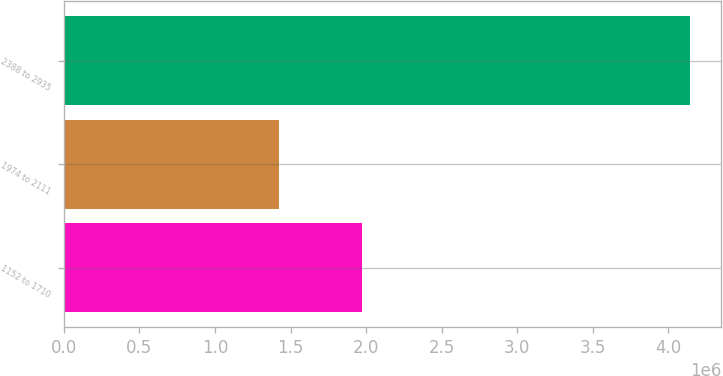<chart> <loc_0><loc_0><loc_500><loc_500><bar_chart><fcel>1152 to 1710<fcel>1974 to 2111<fcel>2388 to 2935<nl><fcel>1.97259e+06<fcel>1.42019e+06<fcel>4.1422e+06<nl></chart> 